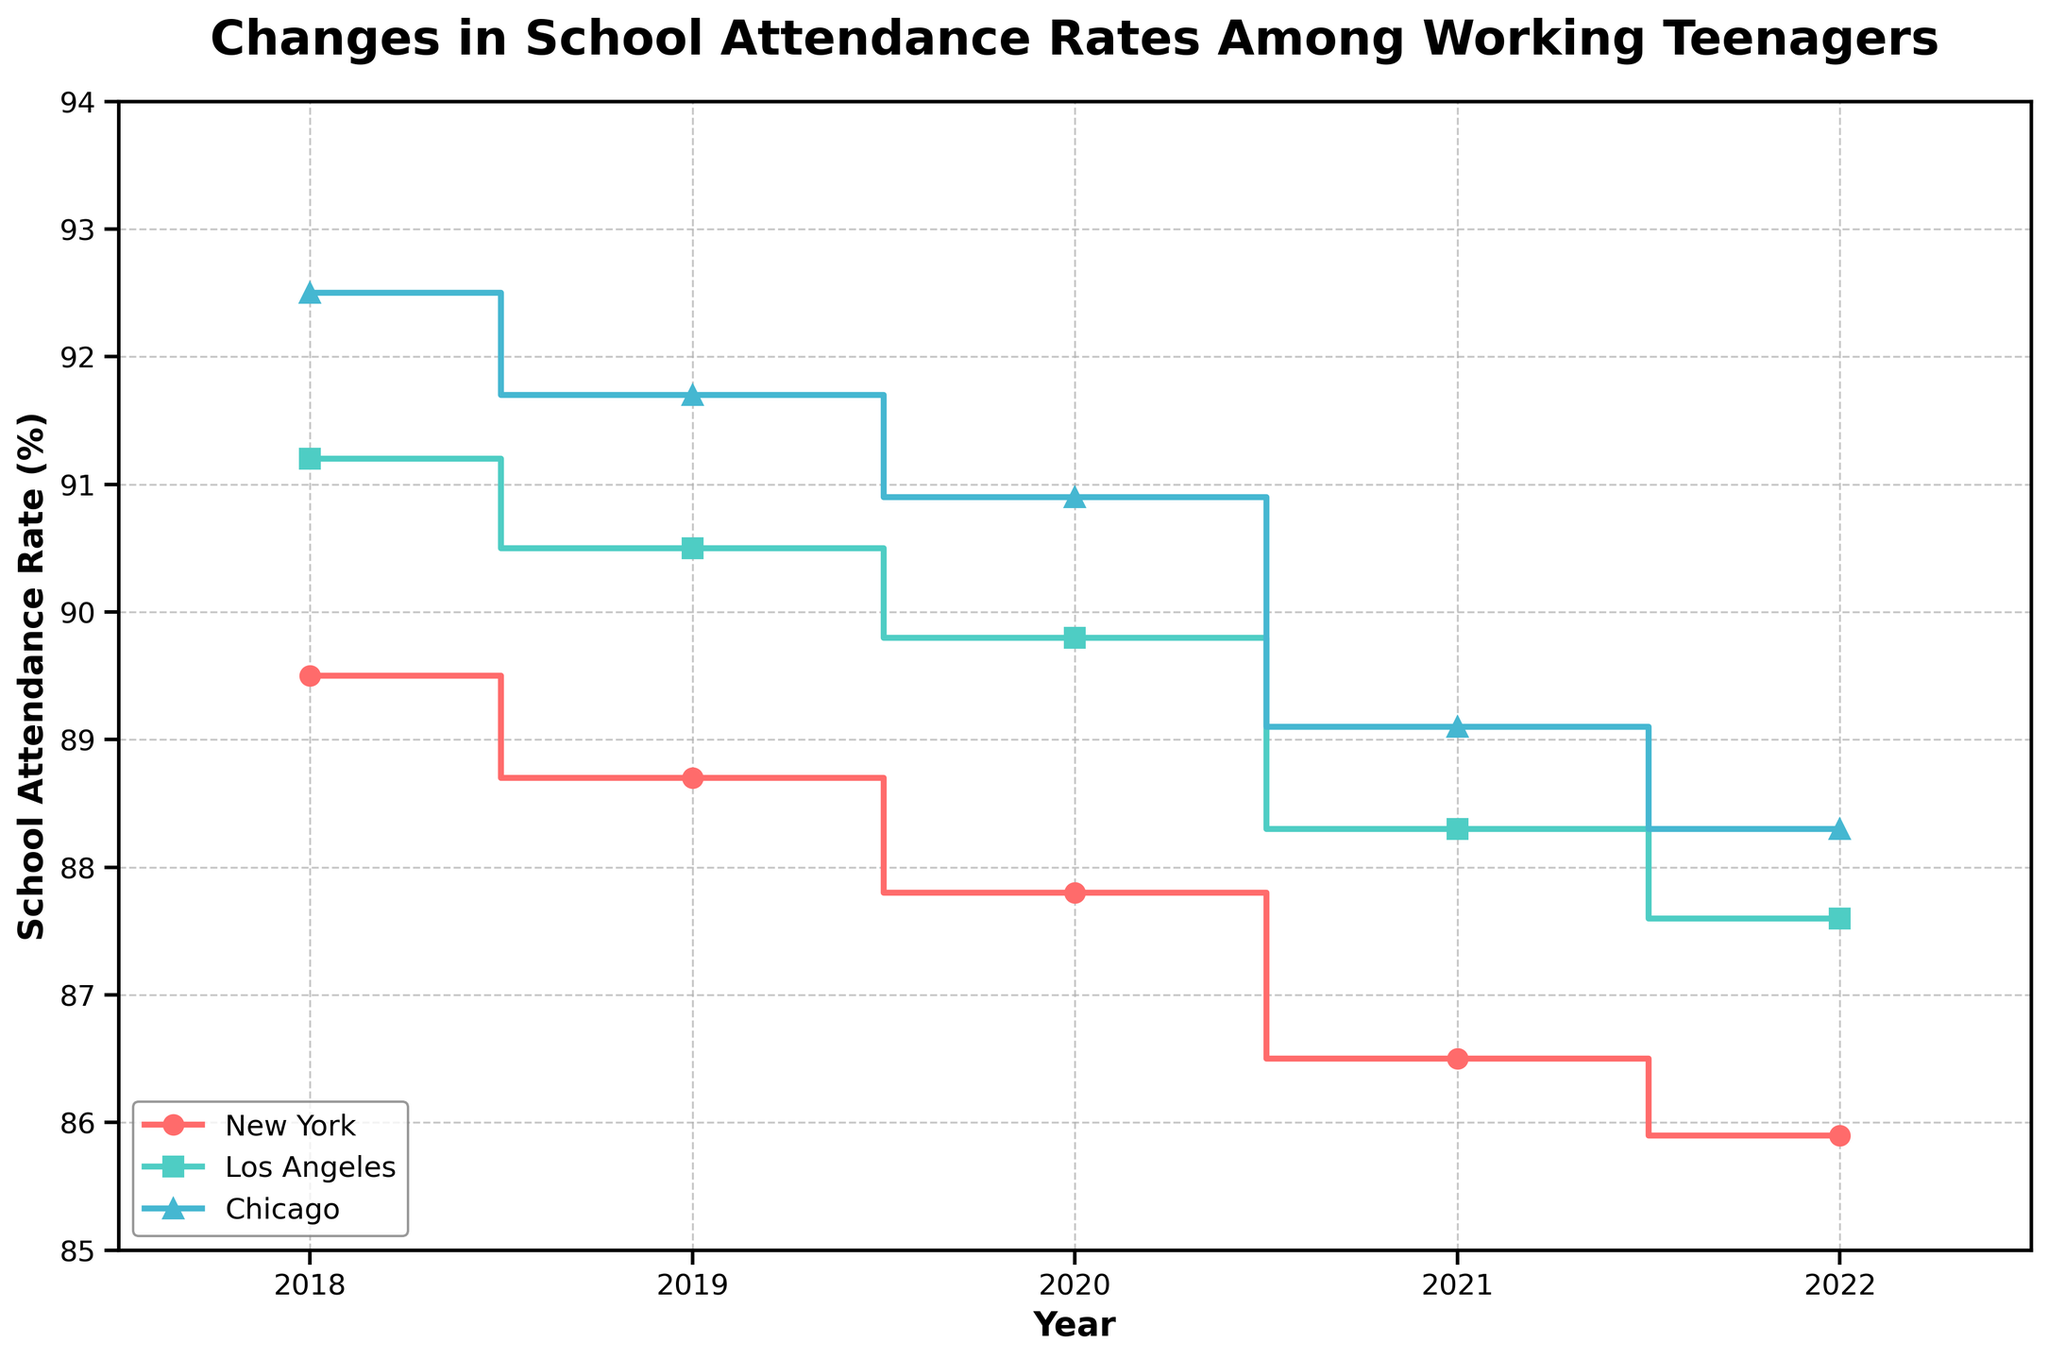What's the title of the figure? The title is written at the top of the figure in a larger and bold font.
Answer: Changes in School Attendance Rates Among Working Teenagers How many cities are represented in the figure? The figure has different colors and legends for each city and shows three distinct cities in the legend.
Answer: Three What is the school attendance rate for Los Angeles in 2018? By looking at the stepping position on the Y-axis for Los Angeles in 2018, it is 91.2.
Answer: 91.2% Which city had the highest school attendance rate in 2022? In 2022, compare the final step positions of each city's line on the Y-axis. Chicago has the highest rate at 88.3.
Answer: Chicago Which city showed the largest decrease in school attendance rates from 2018 to 2022? Calculate the differences for each city. New York: 89.5 - 85.9 = 3.6, Los Angeles: 91.2 - 87.6 = 3.6, Chicago: 92.5 - 88.3 = 4.2. Chicago shows the largest decrease.
Answer: Chicago How many data points are there for each city? Each city's line has markers for each year from 2018 to 2022. Counting these markers, there are five data points for each city.
Answer: Five What is the overall trend of school attendance rates in New York from 2018 to 2022? Observe the step plot for New York; it shows a consistent downward trend over the years.
Answer: Decreasing Which city had the smallest fluctuation in school attendance rates over the given period? Calculate the range (max - min) for each city. New York: 89.5 - 85.9 = 3.6, Los Angeles: 91.2 - 87.6 = 3.6, Chicago: 92.5 - 88.3 = 4.2. Both New York and Los Angeles have the smallest fluctuation of 3.6.
Answer: New York and Los Angeles Comparing 2021 and 2022, which city experienced the biggest drop in school attendance rates? Calculate the difference between 2021 and 2022 for each city. New York: 86.5 - 85.9 = 0.6, Los Angeles: 88.3 - 87.6 = 0.7, Chicago: 89.1 - 88.3 = 0.8. Chicago had the biggest drop.
Answer: Chicago Which city has a steeper decline in school attendance rates from 2018 to 2020? Compare the slopes of the step plots from 2018 to 2020. New York's decline: 89.5 to 87.8 (1.7), Los Angeles's decline: 91.2 to 89.8 (1.4), Chicago's decline: 92.5 to 90.9 (1.6). New York has the steepest decline of 1.7.
Answer: New York 